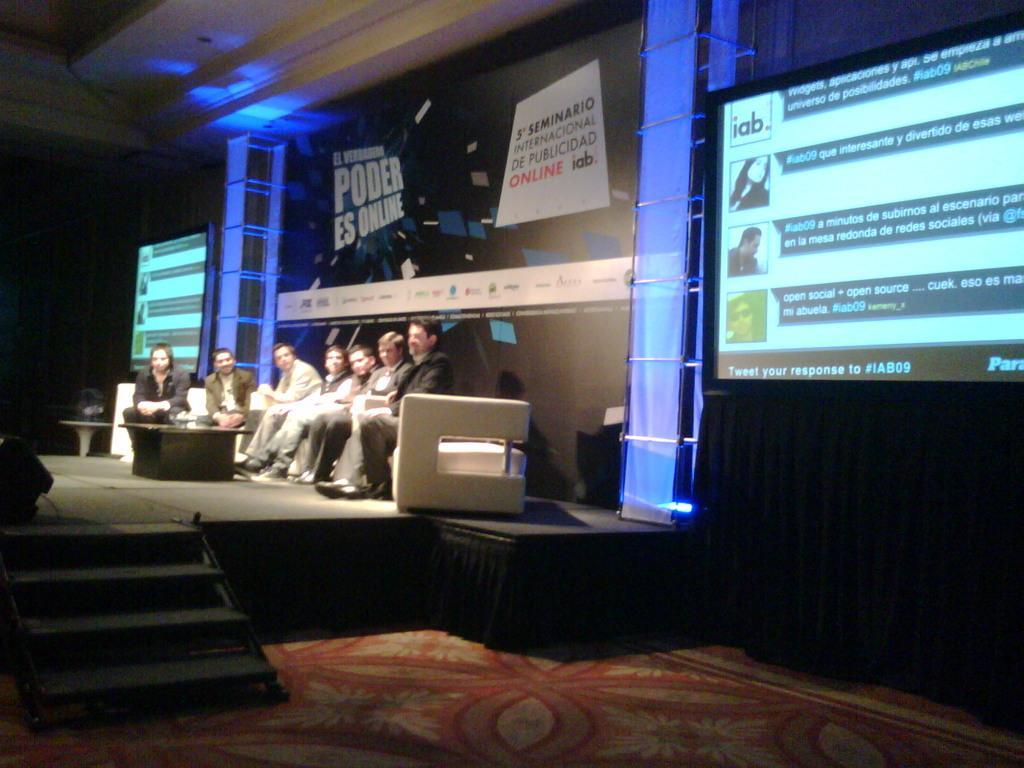In one or two sentences, can you explain what this image depicts? Few persons sitting on the sofa. There is a table. On the background we can see pillar,screen,banner,This is floor. 